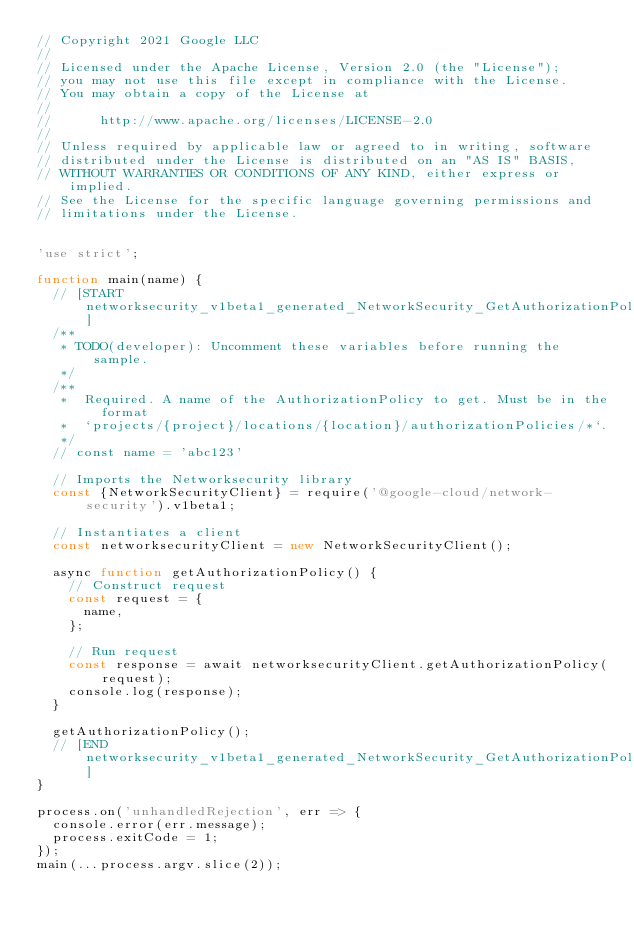<code> <loc_0><loc_0><loc_500><loc_500><_JavaScript_>// Copyright 2021 Google LLC
//
// Licensed under the Apache License, Version 2.0 (the "License");
// you may not use this file except in compliance with the License.
// You may obtain a copy of the License at
//
//      http://www.apache.org/licenses/LICENSE-2.0
//
// Unless required by applicable law or agreed to in writing, software
// distributed under the License is distributed on an "AS IS" BASIS,
// WITHOUT WARRANTIES OR CONDITIONS OF ANY KIND, either express or implied.
// See the License for the specific language governing permissions and
// limitations under the License.


'use strict';

function main(name) {
  // [START networksecurity_v1beta1_generated_NetworkSecurity_GetAuthorizationPolicy_async]
  /**
   * TODO(developer): Uncomment these variables before running the sample.
   */
  /**
   *  Required. A name of the AuthorizationPolicy to get. Must be in the format
   *  `projects/{project}/locations/{location}/authorizationPolicies/*`.
   */
  // const name = 'abc123'

  // Imports the Networksecurity library
  const {NetworkSecurityClient} = require('@google-cloud/network-security').v1beta1;

  // Instantiates a client
  const networksecurityClient = new NetworkSecurityClient();

  async function getAuthorizationPolicy() {
    // Construct request
    const request = {
      name,
    };

    // Run request
    const response = await networksecurityClient.getAuthorizationPolicy(request);
    console.log(response);
  }

  getAuthorizationPolicy();
  // [END networksecurity_v1beta1_generated_NetworkSecurity_GetAuthorizationPolicy_async]
}

process.on('unhandledRejection', err => {
  console.error(err.message);
  process.exitCode = 1;
});
main(...process.argv.slice(2));
</code> 